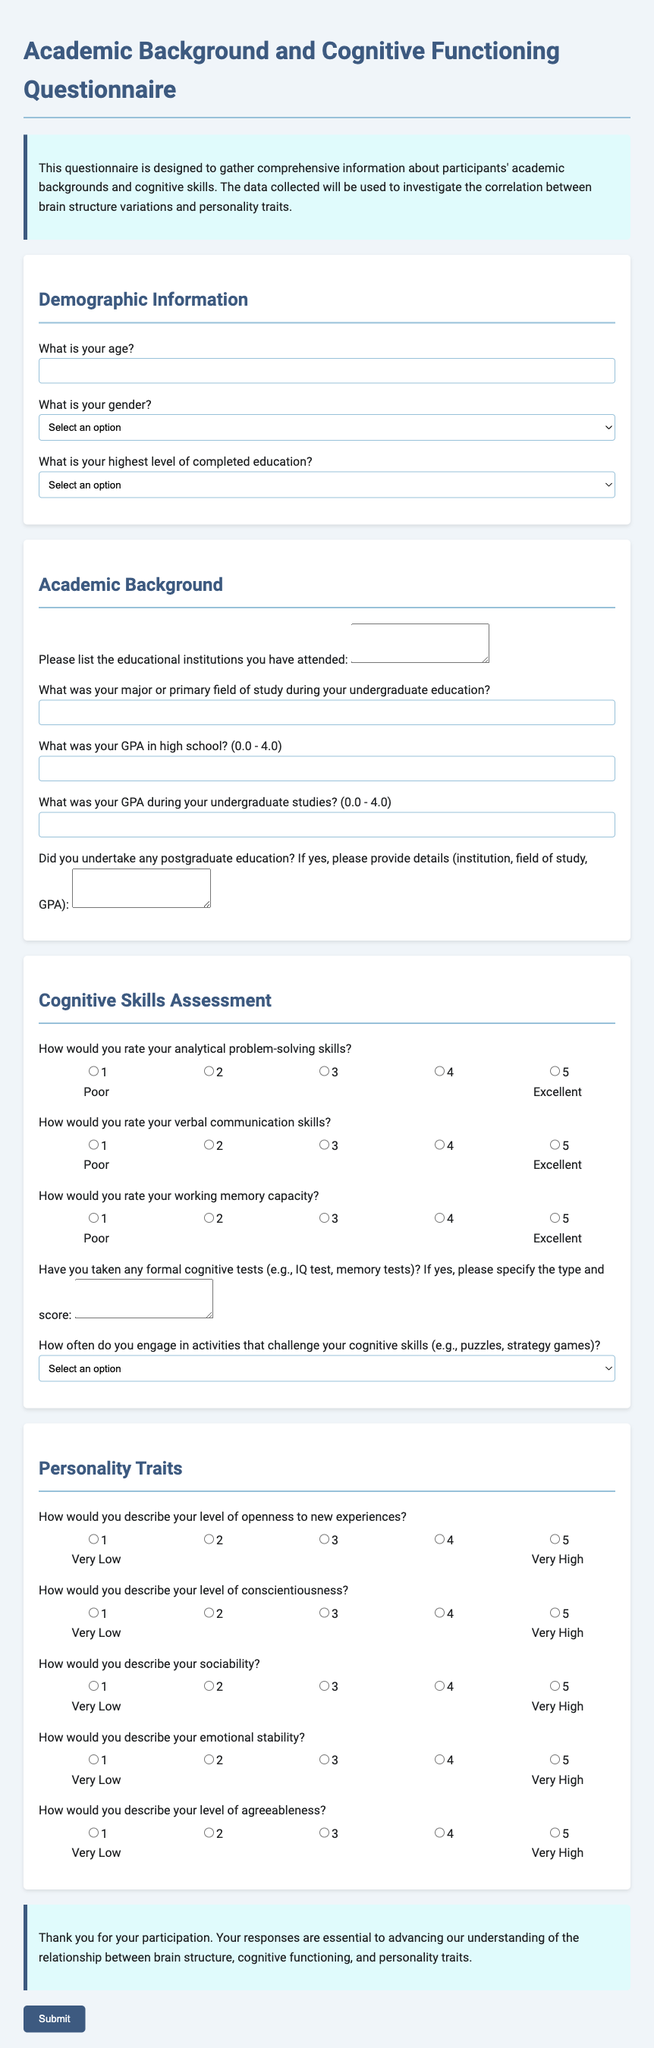What is the title of the questionnaire? The title of the questionnaire is provided at the top of the document.
Answer: Academic Background and Cognitive Functioning Questionnaire How many sections are in the questionnaire? The document has several distinct sections outlined for participants to fill out, including demographic information, academic background, cognitive skills assessment, and personality traits.
Answer: Four What level of education is the highest option listed? The highest level of education provided in the options for the questionnaire is mentioned in the education question.
Answer: Doctorate Degree What is the maximum GPA value participants can report for high school? The document specifies the range for GPA values in the high school question section.
Answer: 4.0 How is 'analytical problem-solving skills' rated in the questionnaire? The rating scale for analytical problem-solving skills is described in the cognitive skills assessment section, indicating a scale of 1 to 5.
Answer: 1 to 5 What type of activities are suggested to challenge cognitive skills? The document explicitly mentions types of activities in relation to cognitive skill engagement.
Answer: Puzzles, strategy games What is the rating scale range for emotional stability? The questionnaire provides a specific range for rating emotional stability.
Answer: 1 to 5 How often do participants engage in cognitive activities measured in the questionnaire? The frequency options regarding cognitive activities are clearly listed in the questionnaire.
Answer: Daily, A few times a week, Weekly, Monthly, Rarely What is the purpose of this questionnaire? The introduction outlines the goal of collecting data to study correlations for research purposes.
Answer: To investigate the correlation between brain structure variations and personality traits 